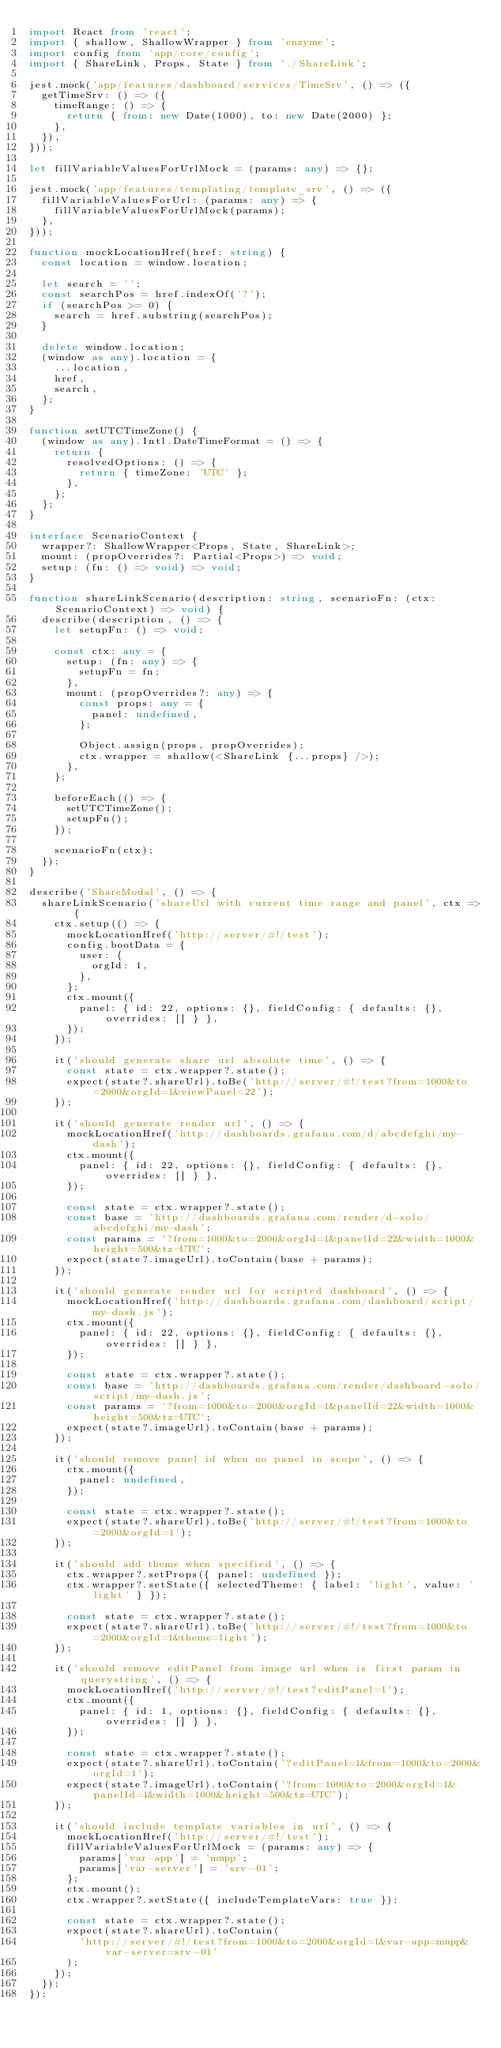<code> <loc_0><loc_0><loc_500><loc_500><_TypeScript_>import React from 'react';
import { shallow, ShallowWrapper } from 'enzyme';
import config from 'app/core/config';
import { ShareLink, Props, State } from './ShareLink';

jest.mock('app/features/dashboard/services/TimeSrv', () => ({
  getTimeSrv: () => ({
    timeRange: () => {
      return { from: new Date(1000), to: new Date(2000) };
    },
  }),
}));

let fillVariableValuesForUrlMock = (params: any) => {};

jest.mock('app/features/templating/template_srv', () => ({
  fillVariableValuesForUrl: (params: any) => {
    fillVariableValuesForUrlMock(params);
  },
}));

function mockLocationHref(href: string) {
  const location = window.location;

  let search = '';
  const searchPos = href.indexOf('?');
  if (searchPos >= 0) {
    search = href.substring(searchPos);
  }

  delete window.location;
  (window as any).location = {
    ...location,
    href,
    search,
  };
}

function setUTCTimeZone() {
  (window as any).Intl.DateTimeFormat = () => {
    return {
      resolvedOptions: () => {
        return { timeZone: 'UTC' };
      },
    };
  };
}

interface ScenarioContext {
  wrapper?: ShallowWrapper<Props, State, ShareLink>;
  mount: (propOverrides?: Partial<Props>) => void;
  setup: (fn: () => void) => void;
}

function shareLinkScenario(description: string, scenarioFn: (ctx: ScenarioContext) => void) {
  describe(description, () => {
    let setupFn: () => void;

    const ctx: any = {
      setup: (fn: any) => {
        setupFn = fn;
      },
      mount: (propOverrides?: any) => {
        const props: any = {
          panel: undefined,
        };

        Object.assign(props, propOverrides);
        ctx.wrapper = shallow(<ShareLink {...props} />);
      },
    };

    beforeEach(() => {
      setUTCTimeZone();
      setupFn();
    });

    scenarioFn(ctx);
  });
}

describe('ShareModal', () => {
  shareLinkScenario('shareUrl with current time range and panel', ctx => {
    ctx.setup(() => {
      mockLocationHref('http://server/#!/test');
      config.bootData = {
        user: {
          orgId: 1,
        },
      };
      ctx.mount({
        panel: { id: 22, options: {}, fieldConfig: { defaults: {}, overrides: [] } },
      });
    });

    it('should generate share url absolute time', () => {
      const state = ctx.wrapper?.state();
      expect(state?.shareUrl).toBe('http://server/#!/test?from=1000&to=2000&orgId=1&viewPanel=22');
    });

    it('should generate render url', () => {
      mockLocationHref('http://dashboards.grafana.com/d/abcdefghi/my-dash');
      ctx.mount({
        panel: { id: 22, options: {}, fieldConfig: { defaults: {}, overrides: [] } },
      });

      const state = ctx.wrapper?.state();
      const base = 'http://dashboards.grafana.com/render/d-solo/abcdefghi/my-dash';
      const params = '?from=1000&to=2000&orgId=1&panelId=22&width=1000&height=500&tz=UTC';
      expect(state?.imageUrl).toContain(base + params);
    });

    it('should generate render url for scripted dashboard', () => {
      mockLocationHref('http://dashboards.grafana.com/dashboard/script/my-dash.js');
      ctx.mount({
        panel: { id: 22, options: {}, fieldConfig: { defaults: {}, overrides: [] } },
      });

      const state = ctx.wrapper?.state();
      const base = 'http://dashboards.grafana.com/render/dashboard-solo/script/my-dash.js';
      const params = '?from=1000&to=2000&orgId=1&panelId=22&width=1000&height=500&tz=UTC';
      expect(state?.imageUrl).toContain(base + params);
    });

    it('should remove panel id when no panel in scope', () => {
      ctx.mount({
        panel: undefined,
      });

      const state = ctx.wrapper?.state();
      expect(state?.shareUrl).toBe('http://server/#!/test?from=1000&to=2000&orgId=1');
    });

    it('should add theme when specified', () => {
      ctx.wrapper?.setProps({ panel: undefined });
      ctx.wrapper?.setState({ selectedTheme: { label: 'light', value: 'light' } });

      const state = ctx.wrapper?.state();
      expect(state?.shareUrl).toBe('http://server/#!/test?from=1000&to=2000&orgId=1&theme=light');
    });

    it('should remove editPanel from image url when is first param in querystring', () => {
      mockLocationHref('http://server/#!/test?editPanel=1');
      ctx.mount({
        panel: { id: 1, options: {}, fieldConfig: { defaults: {}, overrides: [] } },
      });

      const state = ctx.wrapper?.state();
      expect(state?.shareUrl).toContain('?editPanel=1&from=1000&to=2000&orgId=1');
      expect(state?.imageUrl).toContain('?from=1000&to=2000&orgId=1&panelId=1&width=1000&height=500&tz=UTC');
    });

    it('should include template variables in url', () => {
      mockLocationHref('http://server/#!/test');
      fillVariableValuesForUrlMock = (params: any) => {
        params['var-app'] = 'mupp';
        params['var-server'] = 'srv-01';
      };
      ctx.mount();
      ctx.wrapper?.setState({ includeTemplateVars: true });

      const state = ctx.wrapper?.state();
      expect(state?.shareUrl).toContain(
        'http://server/#!/test?from=1000&to=2000&orgId=1&var-app=mupp&var-server=srv-01'
      );
    });
  });
});
</code> 